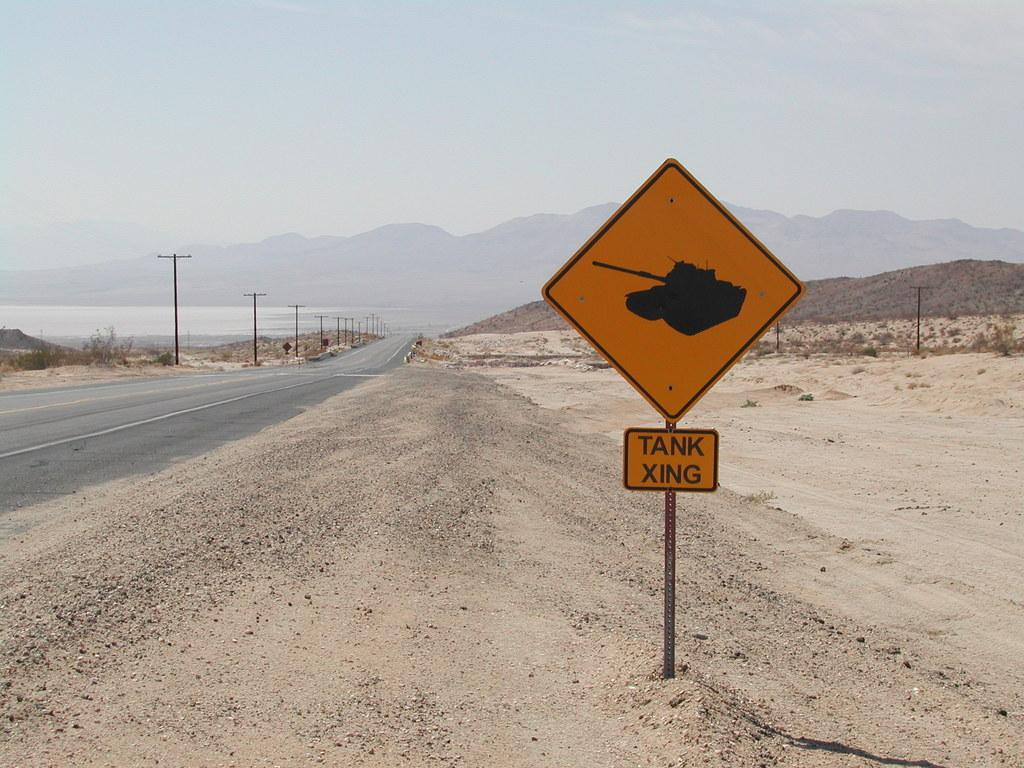<image>
Present a compact description of the photo's key features. a sign with the word tank on it 